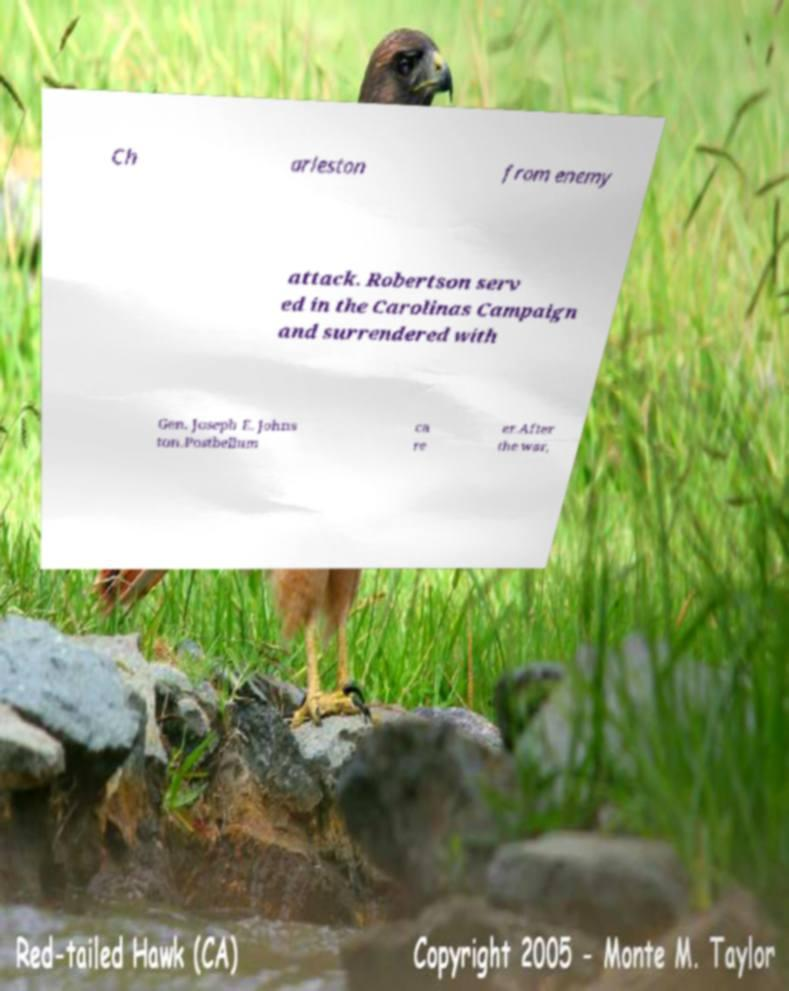Could you extract and type out the text from this image? Ch arleston from enemy attack. Robertson serv ed in the Carolinas Campaign and surrendered with Gen. Joseph E. Johns ton.Postbellum ca re er.After the war, 